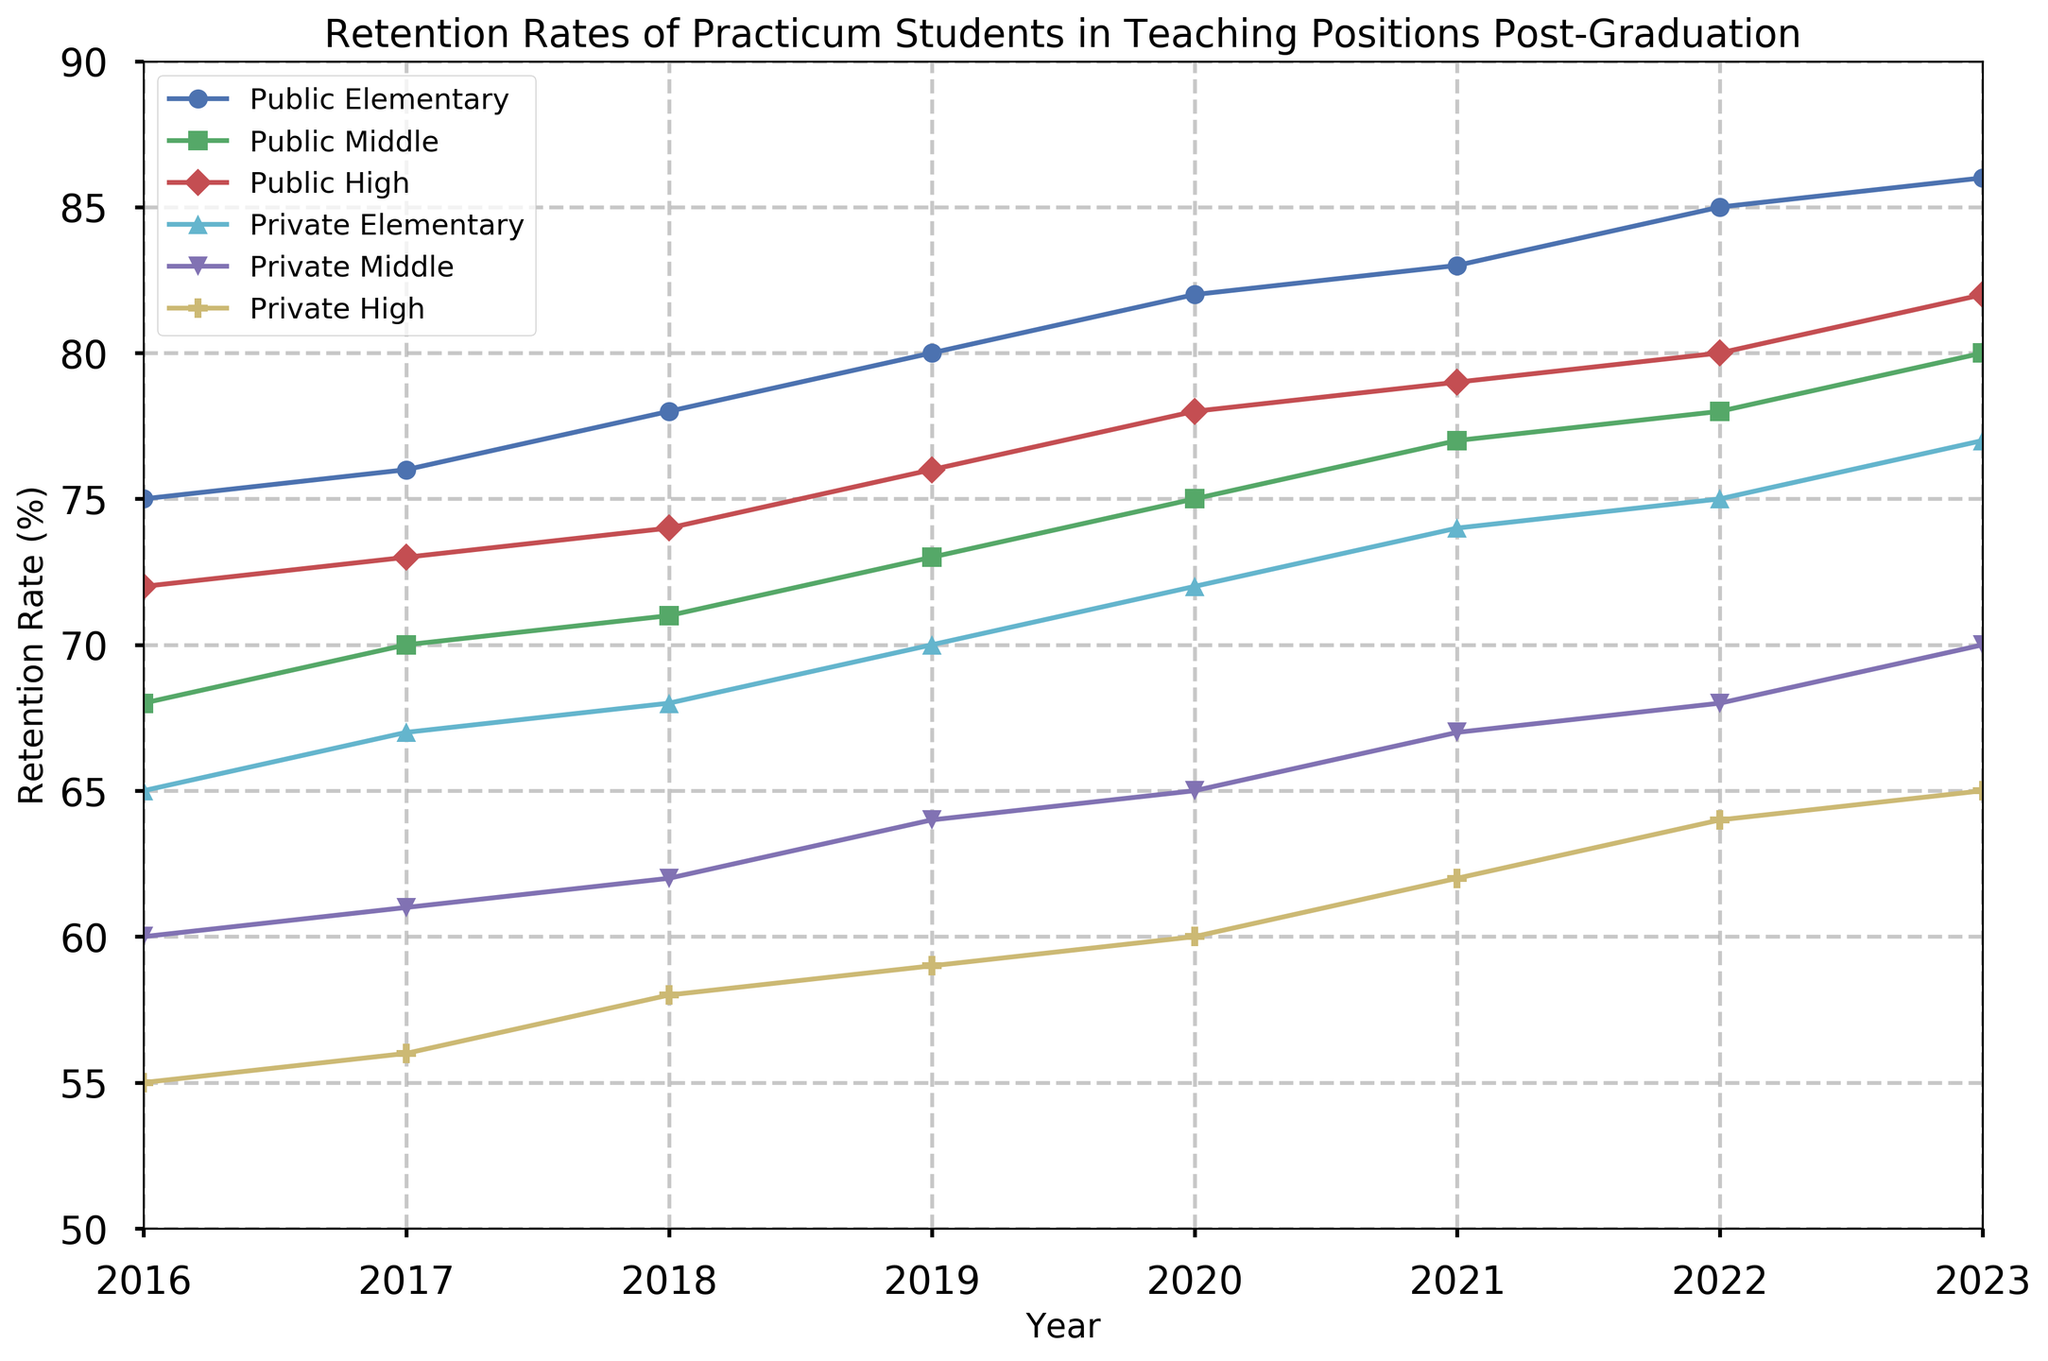What was the retention rate of practicum students in Public High Schools in 2023? The line representing Public High Schools shows a retention rate value of 82 in 2023
Answer: 82% Which school type had the highest retention rate in 2018? Looking at the 2018 data points across all school types, Public Elementary has the highest retention rate of 78
Answer: Public Elementary By how much did the retention rate of Private Middle Schools increase between 2016 and 2023? The retention rate of Private Middle Schools in 2016 was 60, and in 2023 it was 70. The increase is 70 - 60 = 10
Answer: 10% Which school type shows the most overall improvement in retention rates from 2016 to 2023? Subtracting the 2016 values from the 2023 values for each school type: 
Public Elementary: 86 - 75 = 11
Public Middle: 80 - 68 = 12
Public High: 82 - 72 = 10
Private Elementary: 77 - 65 = 12
Private Middle: 70 - 60 = 10
Private High: 65 - 55 = 10
Public Middle and Private Elementary show the largest increase of 12
Answer: Public Middle and Private Elementary What is the average retention rate for Public Middle Schools over the years 2021-2023? The retention rates for Public Middle Schools over 2021, 2022, and 2023 are 77, 78, and 80 respectively. The average is (77 + 78 + 80)/3 = 78.33
Answer: 78.33% Is the retention rate for Private High Schools in 2023 higher than that of Public Elementary Schools in 2016? The retention rate for Private High Schools in 2023 is 65, and for Public Elementary Schools in 2016 it is 75. 65 < 75
Answer: No What was the largest year-over-year increase in retention rate for Public Elementary Schools? Observing the year-over-year changes:
2016-2017: 76 - 75 = 1
2017-2018: 78 - 76 = 2
2018-2019: 80 - 78 = 2
2019-2020: 82 - 80 = 2
2020-2021: 83 - 82 = 1
2021-2022: 85 - 83 = 2
2022-2023: 86 - 85 = 1
The largest increase happened between 2017-2018, 2018-2019, and 2021-2022 with an increase of 2
Answer: 2% How many school types had a retention rate of at least 75% in 2022? Looking at the data points in 2022, the school types with retention rates of at least 75% are:
Public Elementary: 85
Public Middle: 78
Public High: 80
Private Elementary: 75
So, 4 school types had retention rates of at least 75%
Answer: 4 Which school type has the least variability in retention rates across the years? By visually comparing the lines' fluctuations, we see that Private High Schools have the least variability, as their retention rate changes more gradually compared to other types
Answer: Private High Has any school type experienced a decrease in retention rate from one year to the next between 2016 and 2023? All the lines consistently show an increasing trend each year when visually analyzed. No school type has a decline in retention rate
Answer: No 